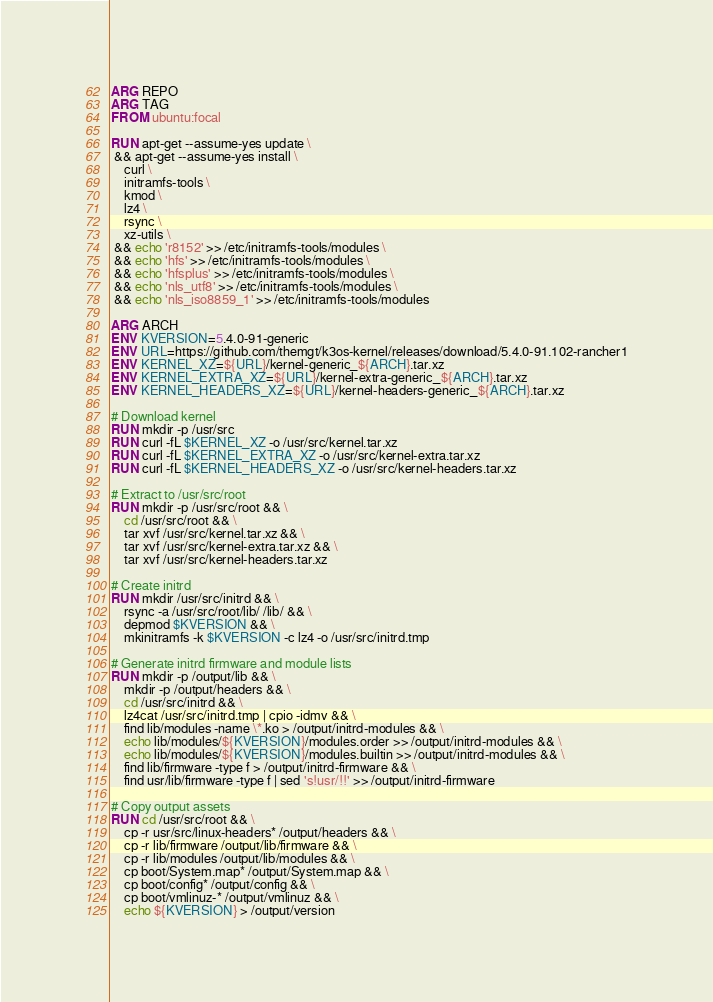<code> <loc_0><loc_0><loc_500><loc_500><_Dockerfile_>ARG REPO
ARG TAG
FROM ubuntu:focal

RUN apt-get --assume-yes update \
 && apt-get --assume-yes install \
    curl \
    initramfs-tools \
    kmod \
    lz4 \
    rsync \
    xz-utils \
 && echo 'r8152' >> /etc/initramfs-tools/modules \
 && echo 'hfs' >> /etc/initramfs-tools/modules \
 && echo 'hfsplus' >> /etc/initramfs-tools/modules \
 && echo 'nls_utf8' >> /etc/initramfs-tools/modules \
 && echo 'nls_iso8859_1' >> /etc/initramfs-tools/modules

ARG ARCH
ENV KVERSION=5.4.0-91-generic
ENV URL=https://github.com/themgt/k3os-kernel/releases/download/5.4.0-91.102-rancher1
ENV KERNEL_XZ=${URL}/kernel-generic_${ARCH}.tar.xz
ENV KERNEL_EXTRA_XZ=${URL}/kernel-extra-generic_${ARCH}.tar.xz
ENV KERNEL_HEADERS_XZ=${URL}/kernel-headers-generic_${ARCH}.tar.xz

# Download kernel
RUN mkdir -p /usr/src
RUN curl -fL $KERNEL_XZ -o /usr/src/kernel.tar.xz
RUN curl -fL $KERNEL_EXTRA_XZ -o /usr/src/kernel-extra.tar.xz
RUN curl -fL $KERNEL_HEADERS_XZ -o /usr/src/kernel-headers.tar.xz

# Extract to /usr/src/root
RUN mkdir -p /usr/src/root && \
    cd /usr/src/root && \
    tar xvf /usr/src/kernel.tar.xz && \
    tar xvf /usr/src/kernel-extra.tar.xz && \
    tar xvf /usr/src/kernel-headers.tar.xz

# Create initrd
RUN mkdir /usr/src/initrd && \
    rsync -a /usr/src/root/lib/ /lib/ && \
    depmod $KVERSION && \
    mkinitramfs -k $KVERSION -c lz4 -o /usr/src/initrd.tmp

# Generate initrd firmware and module lists
RUN mkdir -p /output/lib && \
    mkdir -p /output/headers && \
    cd /usr/src/initrd && \
    lz4cat /usr/src/initrd.tmp | cpio -idmv && \
    find lib/modules -name \*.ko > /output/initrd-modules && \
    echo lib/modules/${KVERSION}/modules.order >> /output/initrd-modules && \
    echo lib/modules/${KVERSION}/modules.builtin >> /output/initrd-modules && \
    find lib/firmware -type f > /output/initrd-firmware && \
    find usr/lib/firmware -type f | sed 's!usr/!!' >> /output/initrd-firmware

# Copy output assets
RUN cd /usr/src/root && \
    cp -r usr/src/linux-headers* /output/headers && \
    cp -r lib/firmware /output/lib/firmware && \
    cp -r lib/modules /output/lib/modules && \
    cp boot/System.map* /output/System.map && \
    cp boot/config* /output/config && \
    cp boot/vmlinuz-* /output/vmlinuz && \
    echo ${KVERSION} > /output/version
</code> 